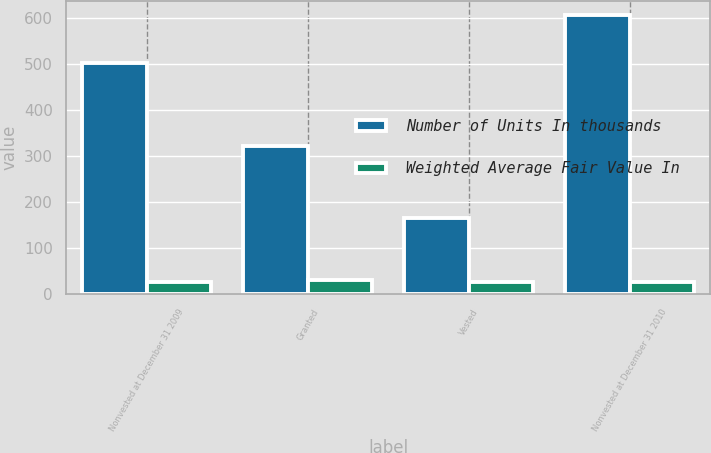<chart> <loc_0><loc_0><loc_500><loc_500><stacked_bar_chart><ecel><fcel>Nonvested at December 31 2009<fcel>Granted<fcel>Vested<fcel>Nonvested at December 31 2010<nl><fcel>Number of Units In thousands<fcel>502<fcel>322<fcel>165<fcel>607<nl><fcel>Weighted Average Fair Value In<fcel>25.57<fcel>30.12<fcel>27.62<fcel>26.41<nl></chart> 